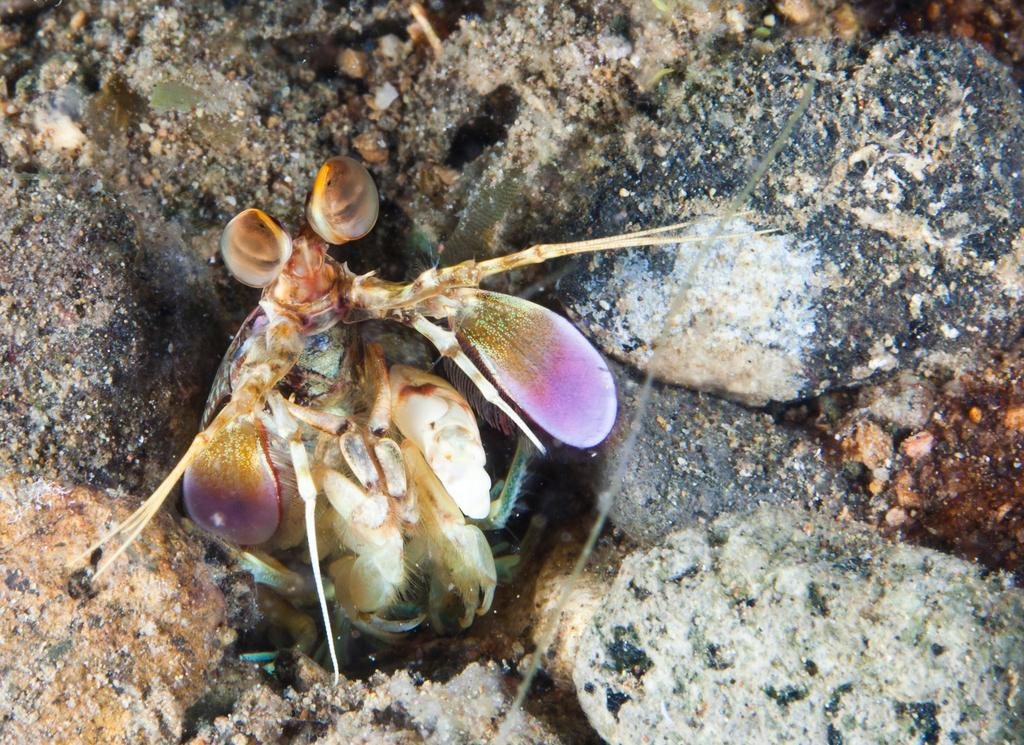What is the main subject in the middle of the image? There is an insect in the middle of the image. What can be seen in the background of the image? There are rocks visible in the background of the image. How many horses are present in the image? There are no horses present in the image; it features an insect and rocks in the background. What type of beetle can be seen in the image? The insect in the image is not specified as a beetle, so it cannot be determined from the image. 